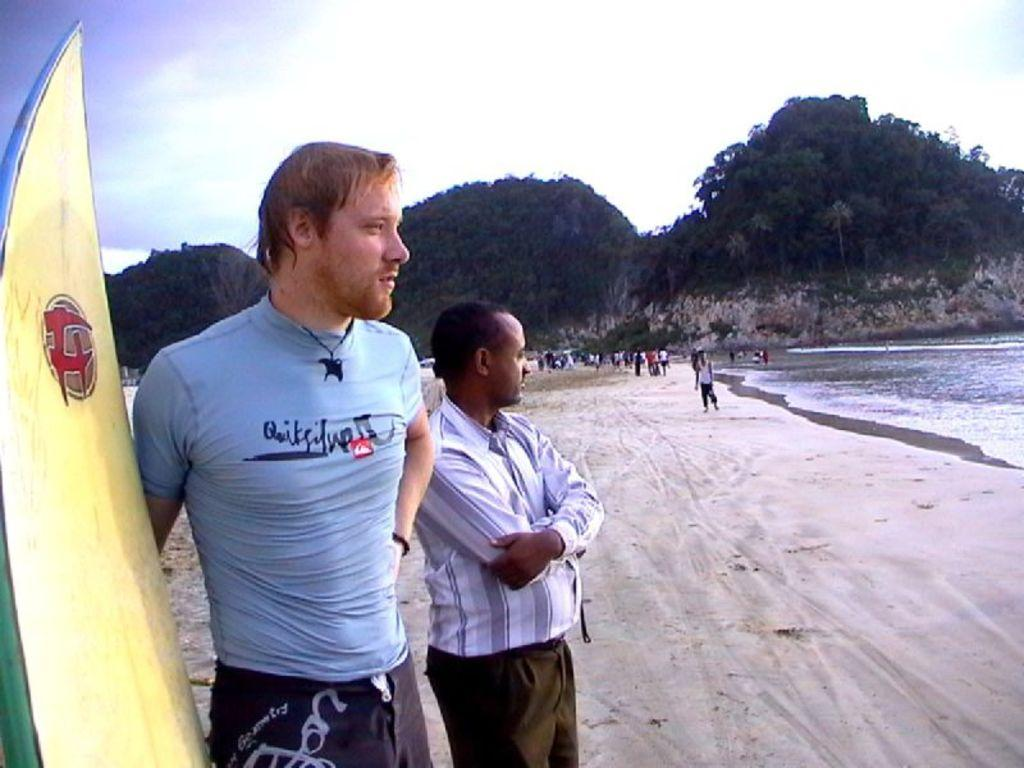What is the man near in the image? The man is near a surfboard in the image. Is there anyone else with the man near the surfboard? Yes, there is another man near the first man. What type of terrain can be seen in the background of the image? There is sand, mountains, and water visible in the background of the image. What part of the natural environment is visible in the background of the image? The sky is visible in the background of the image. What type of necklace is the man wearing in the image? There is no necklace visible on the man in the image. How much wealth can be seen in the image? There is no indication of wealth in the image; it features a man near a surfboard and another man, as well as a natural background. 